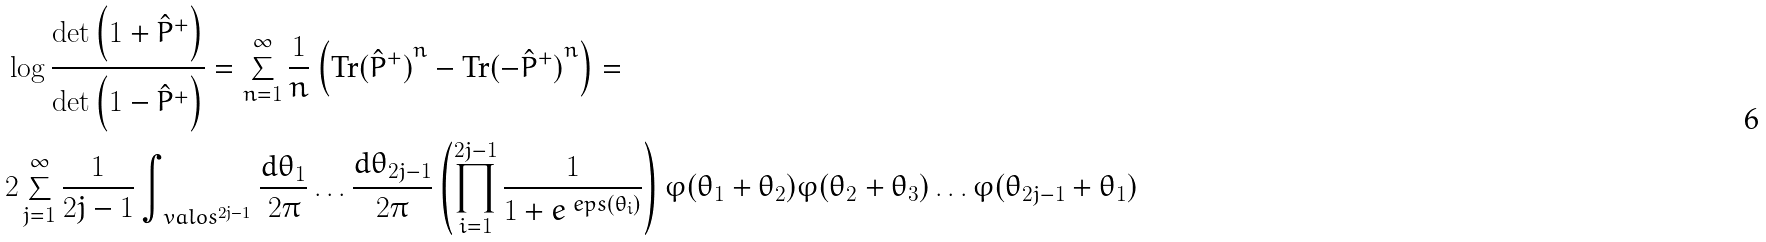Convert formula to latex. <formula><loc_0><loc_0><loc_500><loc_500>& \log \frac { \det \left ( 1 + \hat { P } ^ { + } \right ) } { \det \left ( 1 - \hat { P } ^ { + } \right ) } = \sum _ { n = 1 } ^ { \infty } \frac { 1 } { n } \left ( \text {Tr} { ( \hat { P } ^ { + } ) } ^ { n } - \text {Tr} { ( - \hat { P } ^ { + } ) } ^ { n } \right ) = \\ & 2 \sum _ { j = 1 } ^ { \infty } \frac { 1 } { 2 j - 1 } \int _ { \ v a l o s ^ { 2 j - 1 } } \frac { d \theta _ { 1 } } { 2 \pi } \dots \frac { d \theta _ { 2 j - 1 } } { 2 \pi } \left ( \prod _ { i = 1 } ^ { 2 j - 1 } \frac { 1 } { 1 + e ^ { \ e p s ( \theta _ { i } ) } } \right ) \varphi ( \theta _ { 1 } + \theta _ { 2 } ) \varphi ( \theta _ { 2 } + \theta _ { 3 } ) \dots \varphi ( \theta _ { 2 j - 1 } + \theta _ { 1 } )</formula> 